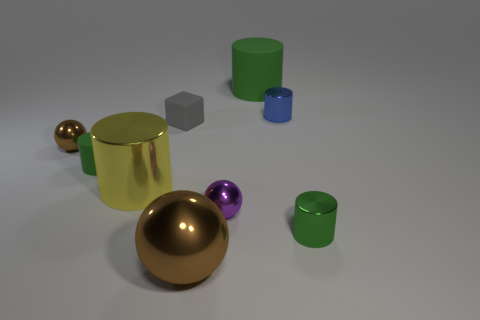Subtract all brown spheres. How many spheres are left? 1 Subtract all brown blocks. How many green cylinders are left? 3 Subtract all yellow cylinders. How many cylinders are left? 4 Subtract 2 cylinders. How many cylinders are left? 3 Subtract all cylinders. How many objects are left? 4 Subtract all cyan cylinders. Subtract all cyan cubes. How many cylinders are left? 5 Add 4 tiny brown rubber spheres. How many tiny brown rubber spheres exist? 4 Subtract 0 red cylinders. How many objects are left? 9 Subtract all brown objects. Subtract all tiny green things. How many objects are left? 5 Add 7 small cylinders. How many small cylinders are left? 10 